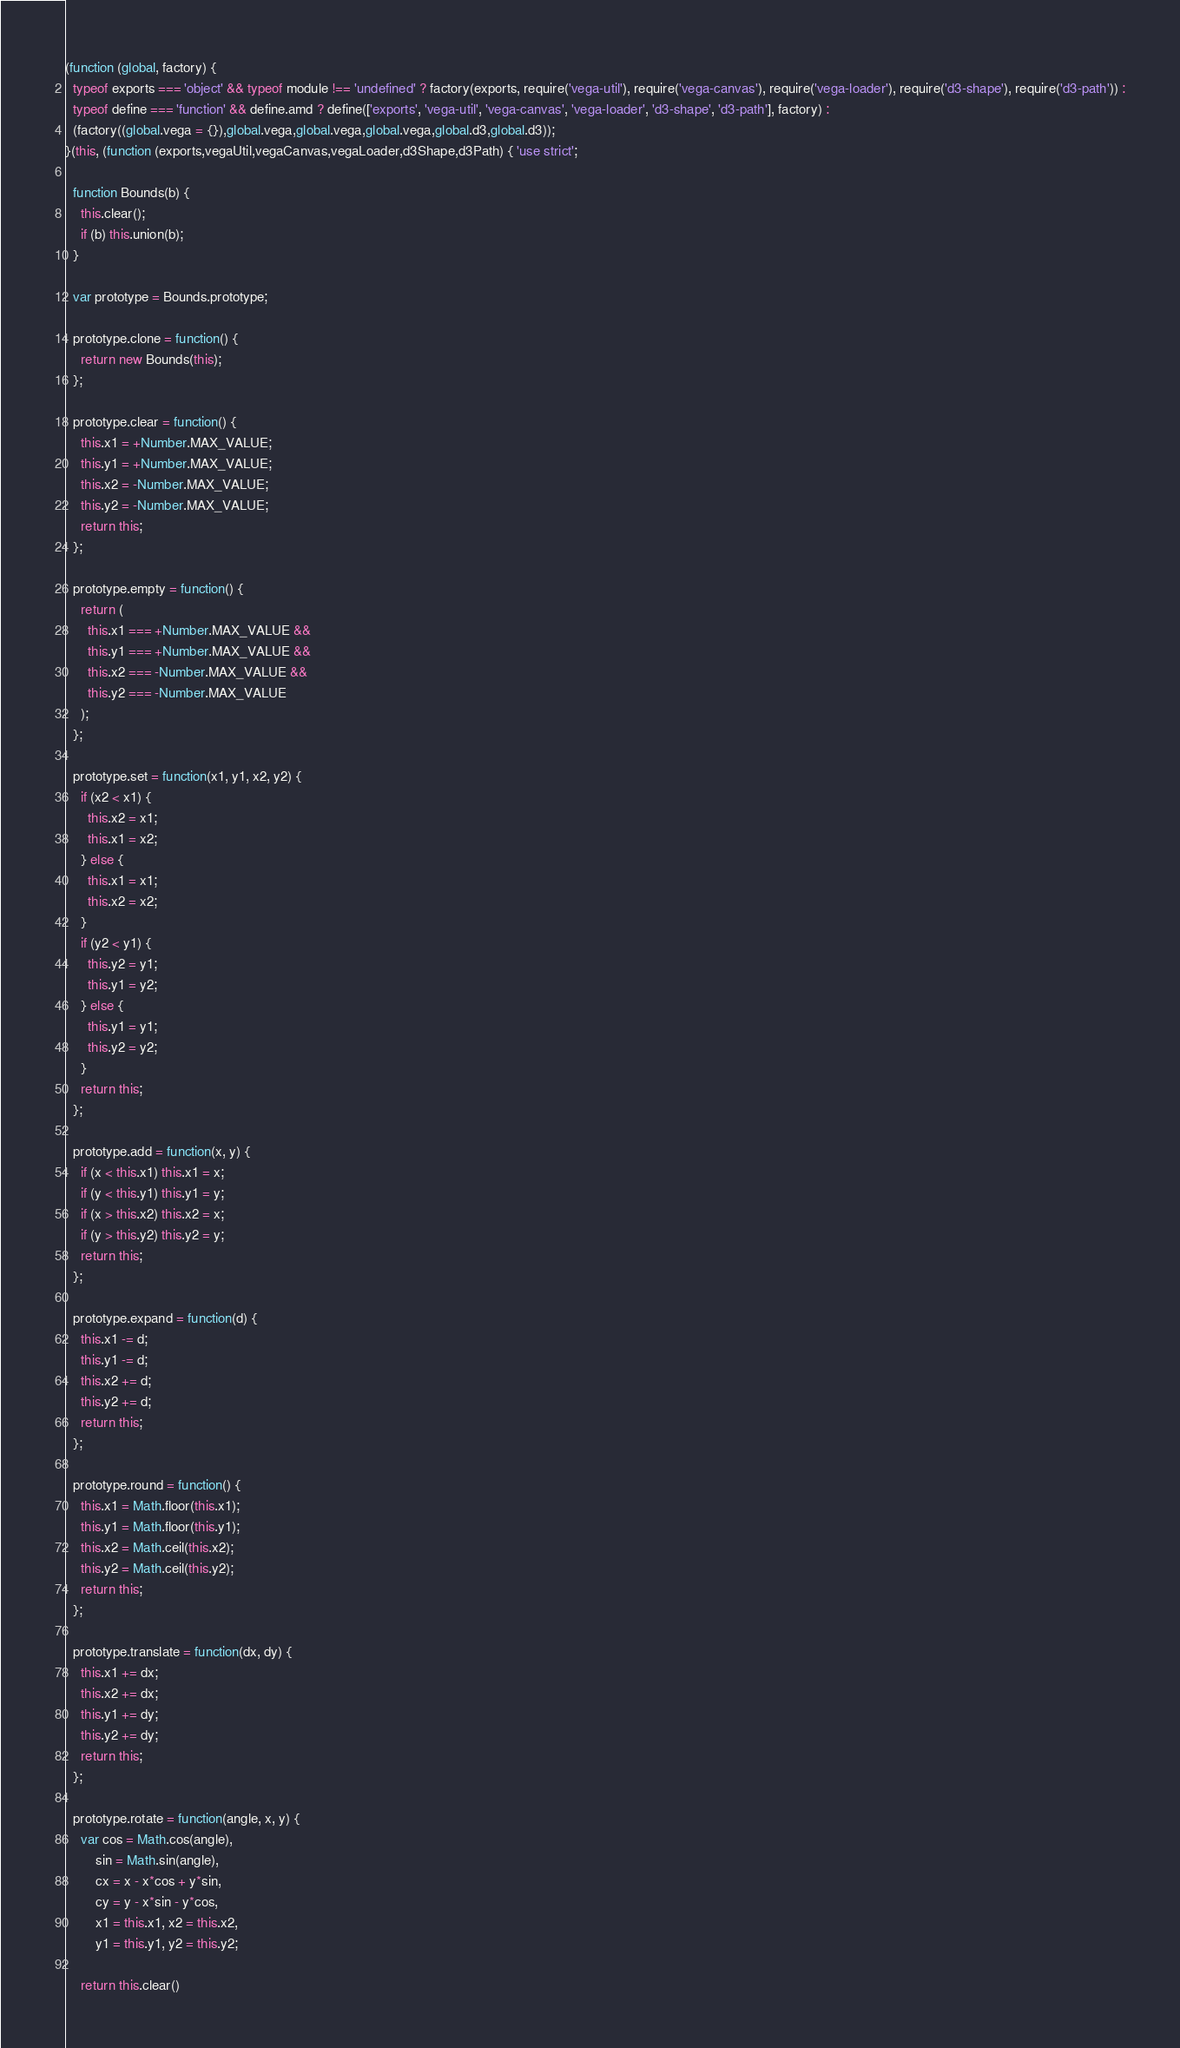<code> <loc_0><loc_0><loc_500><loc_500><_JavaScript_>(function (global, factory) {
  typeof exports === 'object' && typeof module !== 'undefined' ? factory(exports, require('vega-util'), require('vega-canvas'), require('vega-loader'), require('d3-shape'), require('d3-path')) :
  typeof define === 'function' && define.amd ? define(['exports', 'vega-util', 'vega-canvas', 'vega-loader', 'd3-shape', 'd3-path'], factory) :
  (factory((global.vega = {}),global.vega,global.vega,global.vega,global.d3,global.d3));
}(this, (function (exports,vegaUtil,vegaCanvas,vegaLoader,d3Shape,d3Path) { 'use strict';

  function Bounds(b) {
    this.clear();
    if (b) this.union(b);
  }

  var prototype = Bounds.prototype;

  prototype.clone = function() {
    return new Bounds(this);
  };

  prototype.clear = function() {
    this.x1 = +Number.MAX_VALUE;
    this.y1 = +Number.MAX_VALUE;
    this.x2 = -Number.MAX_VALUE;
    this.y2 = -Number.MAX_VALUE;
    return this;
  };

  prototype.empty = function() {
    return (
      this.x1 === +Number.MAX_VALUE &&
      this.y1 === +Number.MAX_VALUE &&
      this.x2 === -Number.MAX_VALUE &&
      this.y2 === -Number.MAX_VALUE
    );
  };

  prototype.set = function(x1, y1, x2, y2) {
    if (x2 < x1) {
      this.x2 = x1;
      this.x1 = x2;
    } else {
      this.x1 = x1;
      this.x2 = x2;
    }
    if (y2 < y1) {
      this.y2 = y1;
      this.y1 = y2;
    } else {
      this.y1 = y1;
      this.y2 = y2;
    }
    return this;
  };

  prototype.add = function(x, y) {
    if (x < this.x1) this.x1 = x;
    if (y < this.y1) this.y1 = y;
    if (x > this.x2) this.x2 = x;
    if (y > this.y2) this.y2 = y;
    return this;
  };

  prototype.expand = function(d) {
    this.x1 -= d;
    this.y1 -= d;
    this.x2 += d;
    this.y2 += d;
    return this;
  };

  prototype.round = function() {
    this.x1 = Math.floor(this.x1);
    this.y1 = Math.floor(this.y1);
    this.x2 = Math.ceil(this.x2);
    this.y2 = Math.ceil(this.y2);
    return this;
  };

  prototype.translate = function(dx, dy) {
    this.x1 += dx;
    this.x2 += dx;
    this.y1 += dy;
    this.y2 += dy;
    return this;
  };

  prototype.rotate = function(angle, x, y) {
    var cos = Math.cos(angle),
        sin = Math.sin(angle),
        cx = x - x*cos + y*sin,
        cy = y - x*sin - y*cos,
        x1 = this.x1, x2 = this.x2,
        y1 = this.y1, y2 = this.y2;

    return this.clear()</code> 